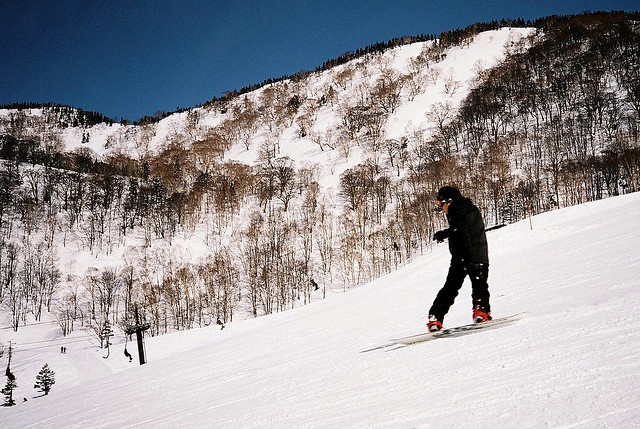Describe the objects in this image and their specific colors. I can see people in black, white, gray, and darkgray tones, snowboard in black, lightgray, darkgray, and gray tones, people in black, white, darkgray, and gray tones, people in black, darkgray, gray, and white tones, and people in black, white, gray, and darkgray tones in this image. 